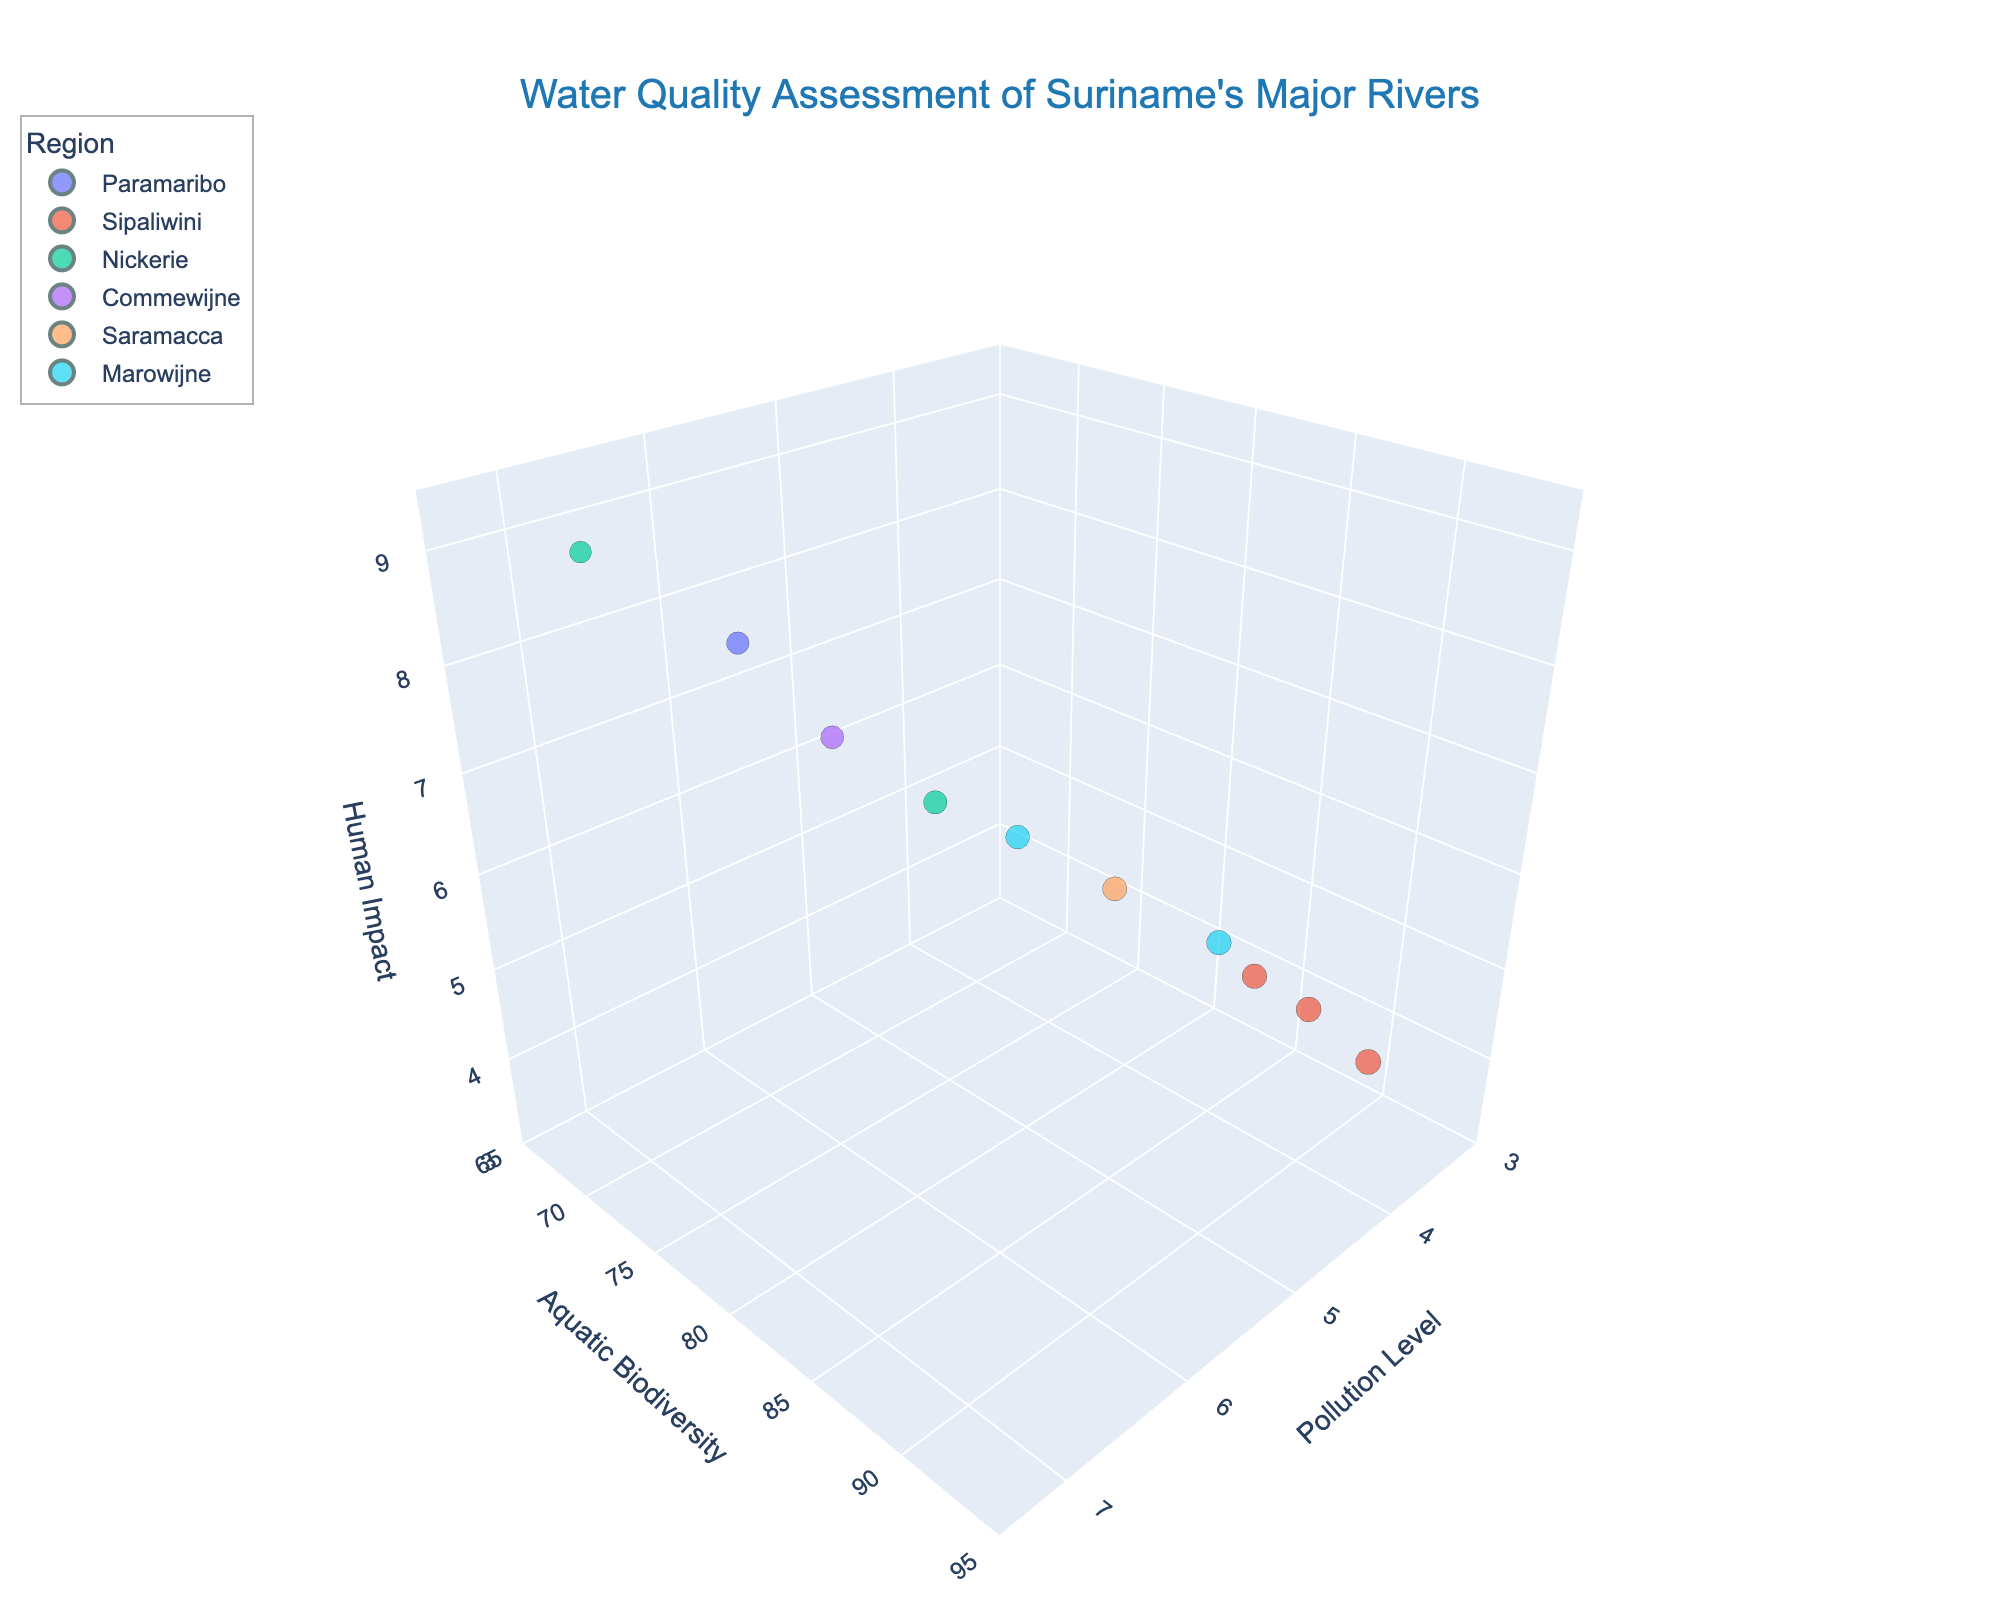What is the title of the chart? The title is located at the top of the chart and indicates the main topic being represented.
Answer: Water Quality Assessment of Suriname's Major Rivers Which river has the highest aquatic biodiversity? By looking at the y-axis, which represents aquatic biodiversity, and identifying the point with the highest value on this axis, we can see that it belongs to the Tapanahony River.
Answer: Tapanahony River How is the human impact of the Suriname River compared to the Nickerie River? The Suriname River has a human impact value of 8.1, while the Nickerie River has a higher value of 8.9, indicating that the Nickerie River experiences greater human impact.
Answer: The Nickerie River has a higher human impact Which region has the most rivers represented in the chart? By counting the number of rivers within each region category shown in the legend, the Sipaliwini region has the most rivers represented with three.
Answer: Sipaliwini What are the ranges of the pollution level, aquatic biodiversity, and human impact axes? By observing the start and end points of each respective axis, the ranges are: Pollution Level [3, 7.5], Aquatic Biodiversity [65, 95], Human Impact [3, 9.5].
Answer: Pollution Level [3, 7.5], Aquatic Biodiversity [65, 95], Human Impact [3, 9.5] Which river has the least pollution level and what is its corresponding aquatic biodiversity? The Tapanahony River has the lowest pollution level at 3.5, and its corresponding aquatic biodiversity value is 91.
Answer: Tapanahony River, 91 How does aquatic biodiversity change with increasing pollution levels? By observing the bubbles along the pollution level axis (x-axis) and noting their aquatic biodiversity (y-axis) values, we can see a trend where high pollution levels generally correspond to lower aquatic biodiversity.
Answer: Generally decreases Among the rivers in the Sipaliwini region, which has the highest pollution level? Within the Sipaliwini region, represented by the same color, the highest pollution level corresponds to the Coppename River at 3.8.
Answer: Coppename River What are the sizes of the bubble markers representing in the chart? The bubble sizes indicate aquatic biodiversity; larger bubbles correspond to higher biodiversity values. This is specified in the chart legend.
Answer: Aquatic Biodiversity Considering all data points, which river has the highest combined value of pollution level, aquatic biodiversity, and human impact? To solve this, sum the values for each data point and find the highest. The Nickerie River has the highest combined value (6.8 + 68 + 8.9 = 83.7).
Answer: Nickerie River 